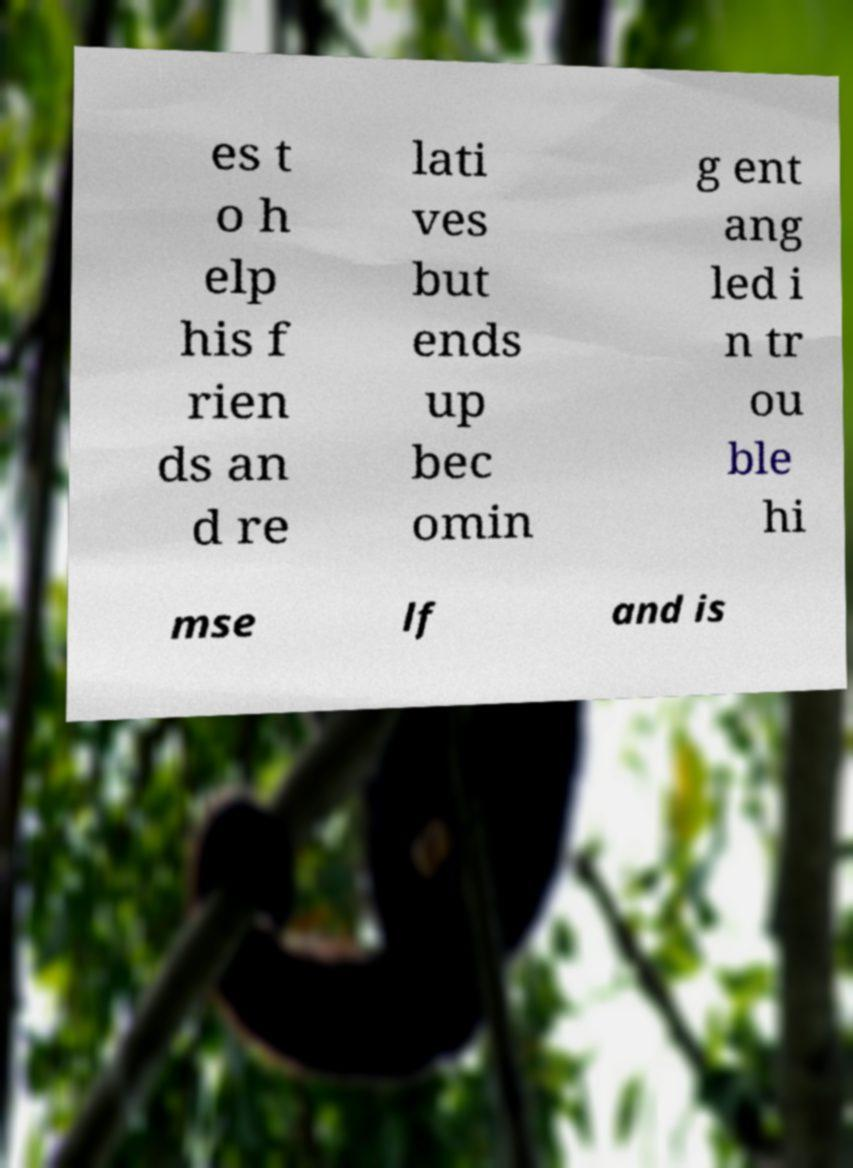Could you extract and type out the text from this image? es t o h elp his f rien ds an d re lati ves but ends up bec omin g ent ang led i n tr ou ble hi mse lf and is 